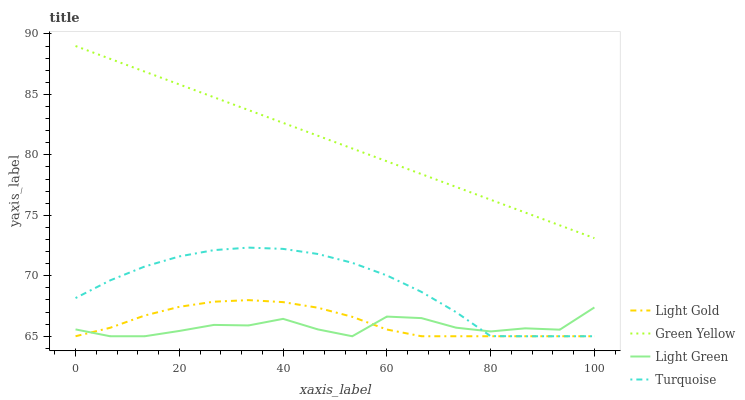Does Light Green have the minimum area under the curve?
Answer yes or no. Yes. Does Light Gold have the minimum area under the curve?
Answer yes or no. No. Does Light Gold have the maximum area under the curve?
Answer yes or no. No. Is Light Gold the smoothest?
Answer yes or no. No. Is Light Gold the roughest?
Answer yes or no. No. Does Green Yellow have the lowest value?
Answer yes or no. No. Does Light Gold have the highest value?
Answer yes or no. No. Is Turquoise less than Green Yellow?
Answer yes or no. Yes. Is Green Yellow greater than Turquoise?
Answer yes or no. Yes. Does Turquoise intersect Green Yellow?
Answer yes or no. No. 